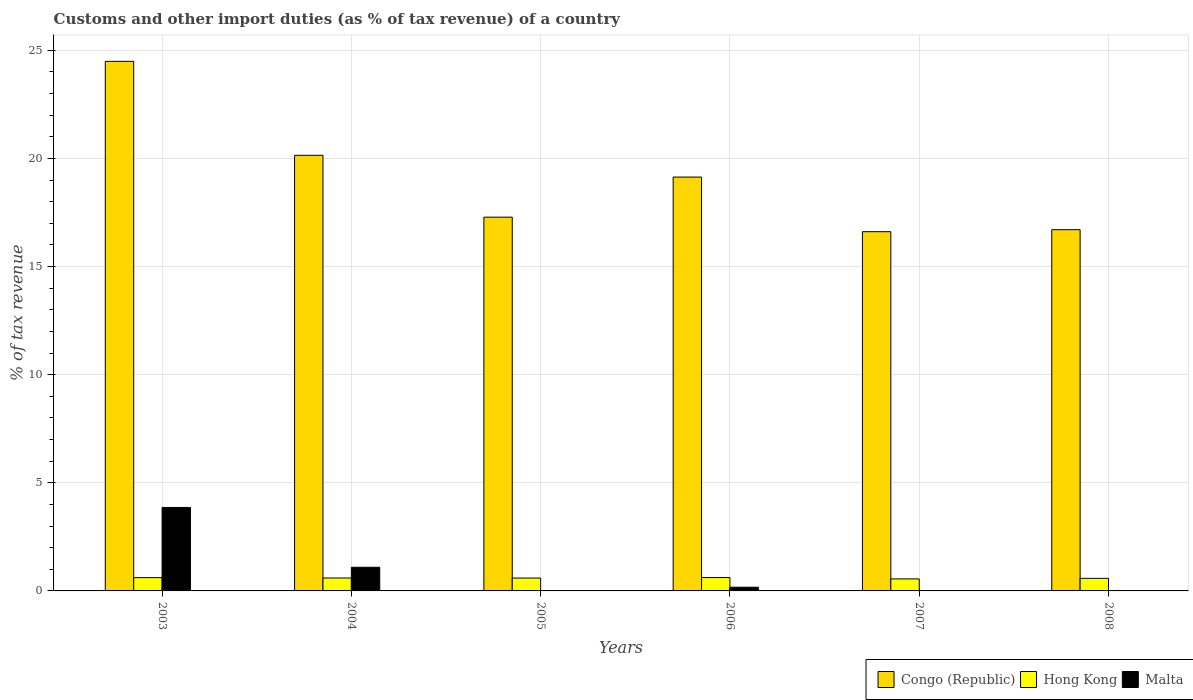How many bars are there on the 1st tick from the left?
Make the answer very short. 3. How many bars are there on the 5th tick from the right?
Keep it short and to the point. 3. What is the label of the 5th group of bars from the left?
Your answer should be very brief. 2007. In how many cases, is the number of bars for a given year not equal to the number of legend labels?
Make the answer very short. 2. What is the percentage of tax revenue from customs in Hong Kong in 2004?
Provide a succinct answer. 0.6. Across all years, what is the maximum percentage of tax revenue from customs in Malta?
Your answer should be compact. 3.86. Across all years, what is the minimum percentage of tax revenue from customs in Congo (Republic)?
Your answer should be very brief. 16.61. What is the total percentage of tax revenue from customs in Malta in the graph?
Your response must be concise. 5.12. What is the difference between the percentage of tax revenue from customs in Congo (Republic) in 2005 and that in 2006?
Provide a succinct answer. -1.85. What is the difference between the percentage of tax revenue from customs in Malta in 2008 and the percentage of tax revenue from customs in Congo (Republic) in 2005?
Your answer should be compact. -17.28. What is the average percentage of tax revenue from customs in Malta per year?
Offer a very short reply. 0.85. In the year 2006, what is the difference between the percentage of tax revenue from customs in Congo (Republic) and percentage of tax revenue from customs in Hong Kong?
Your answer should be very brief. 18.52. What is the ratio of the percentage of tax revenue from customs in Congo (Republic) in 2003 to that in 2004?
Offer a very short reply. 1.22. Is the percentage of tax revenue from customs in Hong Kong in 2004 less than that in 2007?
Your answer should be very brief. No. What is the difference between the highest and the second highest percentage of tax revenue from customs in Congo (Republic)?
Give a very brief answer. 4.34. What is the difference between the highest and the lowest percentage of tax revenue from customs in Congo (Republic)?
Offer a very short reply. 7.88. In how many years, is the percentage of tax revenue from customs in Hong Kong greater than the average percentage of tax revenue from customs in Hong Kong taken over all years?
Your answer should be compact. 4. Is it the case that in every year, the sum of the percentage of tax revenue from customs in Malta and percentage of tax revenue from customs in Congo (Republic) is greater than the percentage of tax revenue from customs in Hong Kong?
Your response must be concise. Yes. Are all the bars in the graph horizontal?
Make the answer very short. No. How many years are there in the graph?
Your answer should be very brief. 6. Where does the legend appear in the graph?
Provide a short and direct response. Bottom right. How are the legend labels stacked?
Offer a terse response. Horizontal. What is the title of the graph?
Provide a short and direct response. Customs and other import duties (as % of tax revenue) of a country. What is the label or title of the Y-axis?
Offer a very short reply. % of tax revenue. What is the % of tax revenue in Congo (Republic) in 2003?
Give a very brief answer. 24.49. What is the % of tax revenue in Hong Kong in 2003?
Make the answer very short. 0.61. What is the % of tax revenue of Malta in 2003?
Ensure brevity in your answer.  3.86. What is the % of tax revenue of Congo (Republic) in 2004?
Your response must be concise. 20.14. What is the % of tax revenue of Hong Kong in 2004?
Make the answer very short. 0.6. What is the % of tax revenue in Malta in 2004?
Give a very brief answer. 1.09. What is the % of tax revenue in Congo (Republic) in 2005?
Your response must be concise. 17.28. What is the % of tax revenue in Hong Kong in 2005?
Keep it short and to the point. 0.59. What is the % of tax revenue in Malta in 2005?
Provide a succinct answer. 6.17825969986944e-10. What is the % of tax revenue of Congo (Republic) in 2006?
Offer a very short reply. 19.14. What is the % of tax revenue in Hong Kong in 2006?
Offer a terse response. 0.62. What is the % of tax revenue of Malta in 2006?
Make the answer very short. 0.17. What is the % of tax revenue in Congo (Republic) in 2007?
Your answer should be very brief. 16.61. What is the % of tax revenue of Hong Kong in 2007?
Ensure brevity in your answer.  0.56. What is the % of tax revenue in Congo (Republic) in 2008?
Offer a very short reply. 16.7. What is the % of tax revenue of Hong Kong in 2008?
Ensure brevity in your answer.  0.58. What is the % of tax revenue of Malta in 2008?
Ensure brevity in your answer.  0. Across all years, what is the maximum % of tax revenue in Congo (Republic)?
Offer a very short reply. 24.49. Across all years, what is the maximum % of tax revenue in Hong Kong?
Provide a short and direct response. 0.62. Across all years, what is the maximum % of tax revenue in Malta?
Make the answer very short. 3.86. Across all years, what is the minimum % of tax revenue of Congo (Republic)?
Offer a very short reply. 16.61. Across all years, what is the minimum % of tax revenue of Hong Kong?
Offer a terse response. 0.56. What is the total % of tax revenue in Congo (Republic) in the graph?
Give a very brief answer. 114.37. What is the total % of tax revenue in Hong Kong in the graph?
Ensure brevity in your answer.  3.56. What is the total % of tax revenue of Malta in the graph?
Give a very brief answer. 5.12. What is the difference between the % of tax revenue of Congo (Republic) in 2003 and that in 2004?
Provide a succinct answer. 4.34. What is the difference between the % of tax revenue in Hong Kong in 2003 and that in 2004?
Your answer should be compact. 0.02. What is the difference between the % of tax revenue of Malta in 2003 and that in 2004?
Keep it short and to the point. 2.77. What is the difference between the % of tax revenue in Congo (Republic) in 2003 and that in 2005?
Offer a very short reply. 7.2. What is the difference between the % of tax revenue in Hong Kong in 2003 and that in 2005?
Offer a terse response. 0.02. What is the difference between the % of tax revenue of Malta in 2003 and that in 2005?
Keep it short and to the point. 3.86. What is the difference between the % of tax revenue of Congo (Republic) in 2003 and that in 2006?
Keep it short and to the point. 5.35. What is the difference between the % of tax revenue of Hong Kong in 2003 and that in 2006?
Offer a terse response. -0. What is the difference between the % of tax revenue in Malta in 2003 and that in 2006?
Keep it short and to the point. 3.69. What is the difference between the % of tax revenue of Congo (Republic) in 2003 and that in 2007?
Your answer should be compact. 7.88. What is the difference between the % of tax revenue in Hong Kong in 2003 and that in 2007?
Keep it short and to the point. 0.06. What is the difference between the % of tax revenue in Congo (Republic) in 2003 and that in 2008?
Your answer should be very brief. 7.78. What is the difference between the % of tax revenue of Congo (Republic) in 2004 and that in 2005?
Your answer should be very brief. 2.86. What is the difference between the % of tax revenue of Hong Kong in 2004 and that in 2005?
Make the answer very short. 0. What is the difference between the % of tax revenue of Malta in 2004 and that in 2005?
Provide a succinct answer. 1.09. What is the difference between the % of tax revenue in Hong Kong in 2004 and that in 2006?
Your response must be concise. -0.02. What is the difference between the % of tax revenue of Malta in 2004 and that in 2006?
Offer a very short reply. 0.92. What is the difference between the % of tax revenue in Congo (Republic) in 2004 and that in 2007?
Keep it short and to the point. 3.53. What is the difference between the % of tax revenue of Hong Kong in 2004 and that in 2007?
Offer a very short reply. 0.04. What is the difference between the % of tax revenue of Congo (Republic) in 2004 and that in 2008?
Ensure brevity in your answer.  3.44. What is the difference between the % of tax revenue of Hong Kong in 2004 and that in 2008?
Offer a terse response. 0.02. What is the difference between the % of tax revenue of Congo (Republic) in 2005 and that in 2006?
Provide a succinct answer. -1.85. What is the difference between the % of tax revenue of Hong Kong in 2005 and that in 2006?
Give a very brief answer. -0.02. What is the difference between the % of tax revenue in Malta in 2005 and that in 2006?
Provide a short and direct response. -0.17. What is the difference between the % of tax revenue of Congo (Republic) in 2005 and that in 2007?
Your answer should be compact. 0.67. What is the difference between the % of tax revenue of Hong Kong in 2005 and that in 2007?
Give a very brief answer. 0.04. What is the difference between the % of tax revenue of Congo (Republic) in 2005 and that in 2008?
Provide a short and direct response. 0.58. What is the difference between the % of tax revenue in Hong Kong in 2005 and that in 2008?
Provide a succinct answer. 0.01. What is the difference between the % of tax revenue of Congo (Republic) in 2006 and that in 2007?
Keep it short and to the point. 2.53. What is the difference between the % of tax revenue of Hong Kong in 2006 and that in 2007?
Provide a succinct answer. 0.06. What is the difference between the % of tax revenue in Congo (Republic) in 2006 and that in 2008?
Keep it short and to the point. 2.43. What is the difference between the % of tax revenue in Hong Kong in 2006 and that in 2008?
Your answer should be very brief. 0.04. What is the difference between the % of tax revenue in Congo (Republic) in 2007 and that in 2008?
Your answer should be very brief. -0.09. What is the difference between the % of tax revenue of Hong Kong in 2007 and that in 2008?
Give a very brief answer. -0.03. What is the difference between the % of tax revenue in Congo (Republic) in 2003 and the % of tax revenue in Hong Kong in 2004?
Ensure brevity in your answer.  23.89. What is the difference between the % of tax revenue in Congo (Republic) in 2003 and the % of tax revenue in Malta in 2004?
Give a very brief answer. 23.39. What is the difference between the % of tax revenue of Hong Kong in 2003 and the % of tax revenue of Malta in 2004?
Offer a terse response. -0.48. What is the difference between the % of tax revenue in Congo (Republic) in 2003 and the % of tax revenue in Hong Kong in 2005?
Your answer should be compact. 23.89. What is the difference between the % of tax revenue of Congo (Republic) in 2003 and the % of tax revenue of Malta in 2005?
Your answer should be very brief. 24.49. What is the difference between the % of tax revenue of Hong Kong in 2003 and the % of tax revenue of Malta in 2005?
Your answer should be compact. 0.61. What is the difference between the % of tax revenue of Congo (Republic) in 2003 and the % of tax revenue of Hong Kong in 2006?
Your response must be concise. 23.87. What is the difference between the % of tax revenue in Congo (Republic) in 2003 and the % of tax revenue in Malta in 2006?
Keep it short and to the point. 24.32. What is the difference between the % of tax revenue in Hong Kong in 2003 and the % of tax revenue in Malta in 2006?
Your answer should be compact. 0.44. What is the difference between the % of tax revenue of Congo (Republic) in 2003 and the % of tax revenue of Hong Kong in 2007?
Provide a short and direct response. 23.93. What is the difference between the % of tax revenue of Congo (Republic) in 2003 and the % of tax revenue of Hong Kong in 2008?
Provide a short and direct response. 23.91. What is the difference between the % of tax revenue in Congo (Republic) in 2004 and the % of tax revenue in Hong Kong in 2005?
Keep it short and to the point. 19.55. What is the difference between the % of tax revenue of Congo (Republic) in 2004 and the % of tax revenue of Malta in 2005?
Make the answer very short. 20.14. What is the difference between the % of tax revenue of Hong Kong in 2004 and the % of tax revenue of Malta in 2005?
Keep it short and to the point. 0.6. What is the difference between the % of tax revenue of Congo (Republic) in 2004 and the % of tax revenue of Hong Kong in 2006?
Make the answer very short. 19.52. What is the difference between the % of tax revenue of Congo (Republic) in 2004 and the % of tax revenue of Malta in 2006?
Make the answer very short. 19.97. What is the difference between the % of tax revenue of Hong Kong in 2004 and the % of tax revenue of Malta in 2006?
Your response must be concise. 0.43. What is the difference between the % of tax revenue in Congo (Republic) in 2004 and the % of tax revenue in Hong Kong in 2007?
Your answer should be compact. 19.59. What is the difference between the % of tax revenue of Congo (Republic) in 2004 and the % of tax revenue of Hong Kong in 2008?
Your answer should be very brief. 19.56. What is the difference between the % of tax revenue of Congo (Republic) in 2005 and the % of tax revenue of Hong Kong in 2006?
Ensure brevity in your answer.  16.66. What is the difference between the % of tax revenue of Congo (Republic) in 2005 and the % of tax revenue of Malta in 2006?
Your response must be concise. 17.11. What is the difference between the % of tax revenue in Hong Kong in 2005 and the % of tax revenue in Malta in 2006?
Offer a terse response. 0.42. What is the difference between the % of tax revenue of Congo (Republic) in 2005 and the % of tax revenue of Hong Kong in 2007?
Keep it short and to the point. 16.73. What is the difference between the % of tax revenue in Congo (Republic) in 2005 and the % of tax revenue in Hong Kong in 2008?
Make the answer very short. 16.7. What is the difference between the % of tax revenue of Congo (Republic) in 2006 and the % of tax revenue of Hong Kong in 2007?
Your response must be concise. 18.58. What is the difference between the % of tax revenue of Congo (Republic) in 2006 and the % of tax revenue of Hong Kong in 2008?
Provide a succinct answer. 18.56. What is the difference between the % of tax revenue in Congo (Republic) in 2007 and the % of tax revenue in Hong Kong in 2008?
Ensure brevity in your answer.  16.03. What is the average % of tax revenue in Congo (Republic) per year?
Offer a very short reply. 19.06. What is the average % of tax revenue of Hong Kong per year?
Keep it short and to the point. 0.59. What is the average % of tax revenue in Malta per year?
Your answer should be very brief. 0.85. In the year 2003, what is the difference between the % of tax revenue of Congo (Republic) and % of tax revenue of Hong Kong?
Give a very brief answer. 23.87. In the year 2003, what is the difference between the % of tax revenue in Congo (Republic) and % of tax revenue in Malta?
Your response must be concise. 20.63. In the year 2003, what is the difference between the % of tax revenue in Hong Kong and % of tax revenue in Malta?
Give a very brief answer. -3.24. In the year 2004, what is the difference between the % of tax revenue of Congo (Republic) and % of tax revenue of Hong Kong?
Your answer should be compact. 19.55. In the year 2004, what is the difference between the % of tax revenue in Congo (Republic) and % of tax revenue in Malta?
Give a very brief answer. 19.05. In the year 2004, what is the difference between the % of tax revenue of Hong Kong and % of tax revenue of Malta?
Make the answer very short. -0.5. In the year 2005, what is the difference between the % of tax revenue of Congo (Republic) and % of tax revenue of Hong Kong?
Your response must be concise. 16.69. In the year 2005, what is the difference between the % of tax revenue in Congo (Republic) and % of tax revenue in Malta?
Provide a succinct answer. 17.28. In the year 2005, what is the difference between the % of tax revenue in Hong Kong and % of tax revenue in Malta?
Ensure brevity in your answer.  0.59. In the year 2006, what is the difference between the % of tax revenue of Congo (Republic) and % of tax revenue of Hong Kong?
Make the answer very short. 18.52. In the year 2006, what is the difference between the % of tax revenue of Congo (Republic) and % of tax revenue of Malta?
Give a very brief answer. 18.97. In the year 2006, what is the difference between the % of tax revenue of Hong Kong and % of tax revenue of Malta?
Provide a short and direct response. 0.45. In the year 2007, what is the difference between the % of tax revenue of Congo (Republic) and % of tax revenue of Hong Kong?
Give a very brief answer. 16.06. In the year 2008, what is the difference between the % of tax revenue of Congo (Republic) and % of tax revenue of Hong Kong?
Ensure brevity in your answer.  16.12. What is the ratio of the % of tax revenue of Congo (Republic) in 2003 to that in 2004?
Give a very brief answer. 1.22. What is the ratio of the % of tax revenue of Hong Kong in 2003 to that in 2004?
Make the answer very short. 1.03. What is the ratio of the % of tax revenue in Malta in 2003 to that in 2004?
Give a very brief answer. 3.53. What is the ratio of the % of tax revenue of Congo (Republic) in 2003 to that in 2005?
Provide a succinct answer. 1.42. What is the ratio of the % of tax revenue of Hong Kong in 2003 to that in 2005?
Give a very brief answer. 1.03. What is the ratio of the % of tax revenue in Malta in 2003 to that in 2005?
Keep it short and to the point. 6.25e+09. What is the ratio of the % of tax revenue in Congo (Republic) in 2003 to that in 2006?
Ensure brevity in your answer.  1.28. What is the ratio of the % of tax revenue in Hong Kong in 2003 to that in 2006?
Your answer should be compact. 0.99. What is the ratio of the % of tax revenue in Malta in 2003 to that in 2006?
Offer a terse response. 22.55. What is the ratio of the % of tax revenue in Congo (Republic) in 2003 to that in 2007?
Give a very brief answer. 1.47. What is the ratio of the % of tax revenue in Hong Kong in 2003 to that in 2007?
Provide a short and direct response. 1.11. What is the ratio of the % of tax revenue in Congo (Republic) in 2003 to that in 2008?
Your answer should be very brief. 1.47. What is the ratio of the % of tax revenue of Hong Kong in 2003 to that in 2008?
Ensure brevity in your answer.  1.06. What is the ratio of the % of tax revenue of Congo (Republic) in 2004 to that in 2005?
Offer a very short reply. 1.17. What is the ratio of the % of tax revenue of Malta in 2004 to that in 2005?
Give a very brief answer. 1.77e+09. What is the ratio of the % of tax revenue of Congo (Republic) in 2004 to that in 2006?
Provide a succinct answer. 1.05. What is the ratio of the % of tax revenue in Hong Kong in 2004 to that in 2006?
Make the answer very short. 0.97. What is the ratio of the % of tax revenue in Malta in 2004 to that in 2006?
Offer a very short reply. 6.39. What is the ratio of the % of tax revenue of Congo (Republic) in 2004 to that in 2007?
Give a very brief answer. 1.21. What is the ratio of the % of tax revenue of Hong Kong in 2004 to that in 2007?
Ensure brevity in your answer.  1.08. What is the ratio of the % of tax revenue in Congo (Republic) in 2004 to that in 2008?
Ensure brevity in your answer.  1.21. What is the ratio of the % of tax revenue of Hong Kong in 2004 to that in 2008?
Your response must be concise. 1.03. What is the ratio of the % of tax revenue in Congo (Republic) in 2005 to that in 2006?
Your response must be concise. 0.9. What is the ratio of the % of tax revenue of Hong Kong in 2005 to that in 2006?
Offer a terse response. 0.96. What is the ratio of the % of tax revenue in Congo (Republic) in 2005 to that in 2007?
Offer a terse response. 1.04. What is the ratio of the % of tax revenue in Hong Kong in 2005 to that in 2007?
Your answer should be compact. 1.07. What is the ratio of the % of tax revenue in Congo (Republic) in 2005 to that in 2008?
Ensure brevity in your answer.  1.03. What is the ratio of the % of tax revenue of Hong Kong in 2005 to that in 2008?
Provide a short and direct response. 1.02. What is the ratio of the % of tax revenue in Congo (Republic) in 2006 to that in 2007?
Provide a succinct answer. 1.15. What is the ratio of the % of tax revenue in Hong Kong in 2006 to that in 2007?
Provide a short and direct response. 1.11. What is the ratio of the % of tax revenue in Congo (Republic) in 2006 to that in 2008?
Offer a terse response. 1.15. What is the ratio of the % of tax revenue of Hong Kong in 2006 to that in 2008?
Provide a short and direct response. 1.06. What is the ratio of the % of tax revenue of Hong Kong in 2007 to that in 2008?
Offer a terse response. 0.96. What is the difference between the highest and the second highest % of tax revenue of Congo (Republic)?
Give a very brief answer. 4.34. What is the difference between the highest and the second highest % of tax revenue in Hong Kong?
Your response must be concise. 0. What is the difference between the highest and the second highest % of tax revenue of Malta?
Provide a succinct answer. 2.77. What is the difference between the highest and the lowest % of tax revenue of Congo (Republic)?
Make the answer very short. 7.88. What is the difference between the highest and the lowest % of tax revenue in Hong Kong?
Keep it short and to the point. 0.06. What is the difference between the highest and the lowest % of tax revenue of Malta?
Your answer should be very brief. 3.86. 